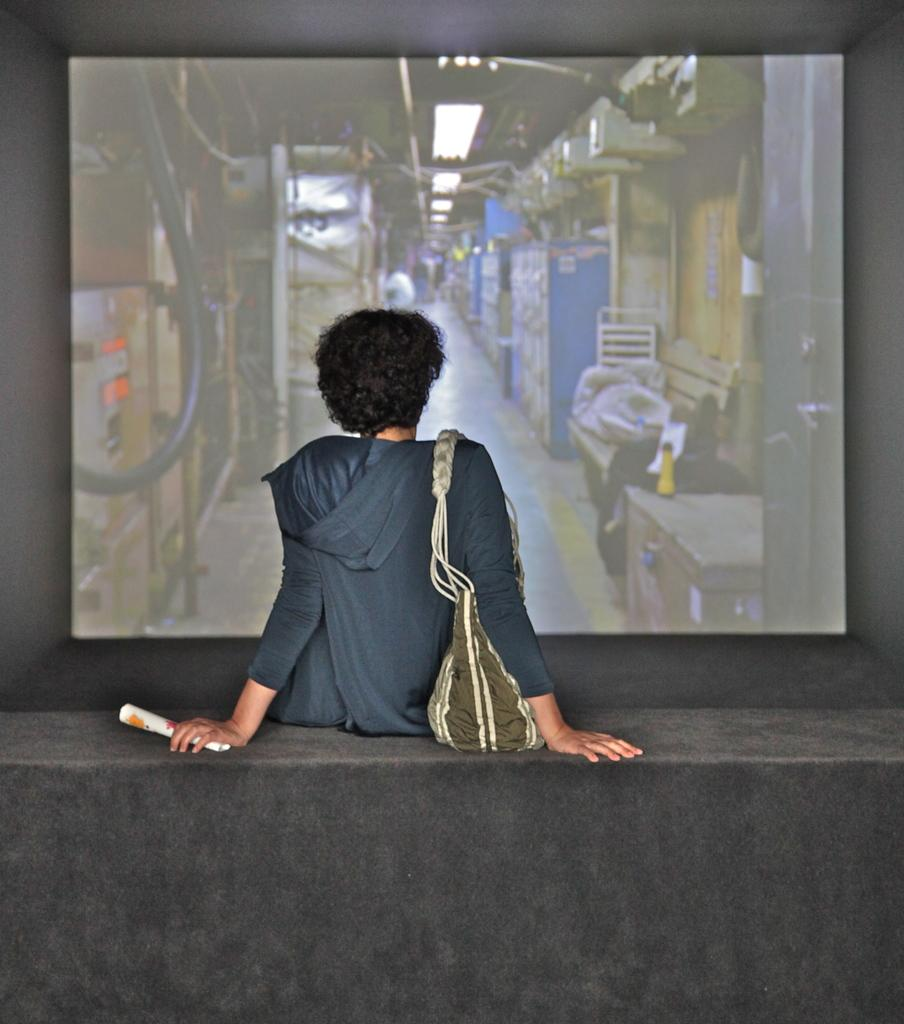Who is present in the image? There is a person in the image. What is the person doing in the image? The person is sitting on a wall. What is the person holding in the image? The person is holding a paper. What is the person wearing in the image? The person is wearing a handbag. What is in front of the person in the image? There is a screen in front of the person. Can you see a donkey carrying a coach in the image? No, there is no donkey or coach present in the image. 